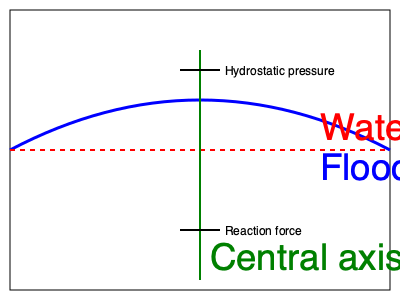Analyze the stress distribution on the Mose floodgate shown in the cross-sectional diagram. What is the primary factor determining the maximum bending stress in the gate, and where is this stress likely to occur? To analyze the stress distribution on the Mose floodgate, we need to consider several factors:

1. Hydrostatic pressure: The water exerts a distributed load on the gate, increasing with depth. This is represented by the blue curve.

2. Reaction forces: The gate is supported at its base, providing a reaction force to counteract the water pressure. This is shown at the bottom of the green central axis.

3. Gate geometry: The gate has a curved shape, which affects how it resists the applied loads.

4. Bending moment: The combination of hydrostatic pressure and reaction forces creates a bending moment in the gate.

5. Stress distribution: The bending stress varies along the gate's cross-section, with maximum values at the outermost fibers.

To determine the primary factor for maximum bending stress:

a) The bending moment is highest at the location where the difference between the hydrostatic pressure and the reaction force is greatest.

b) This typically occurs near the middle of the gate's height, where the hydrostatic pressure is significant, but the effect of the reaction force is reduced.

c) The maximum bending stress ($\sigma_{max}$) is given by the formula:

   $$\sigma_{max} = \frac{My}{I}$$

   Where $M$ is the bending moment, $y$ is the distance from the neutral axis to the outermost fiber, and $I$ is the moment of inertia of the cross-section.

d) The primary factor determining the maximum bending stress is the bending moment ($M$), which is directly related to the hydrostatic pressure distribution.

e) The location of maximum stress will be at the outermost fibers of the gate's cross-section, where $y$ is largest, coinciding with the point of maximum bending moment.
Answer: Hydrostatic pressure distribution; near mid-height at outermost fibers 